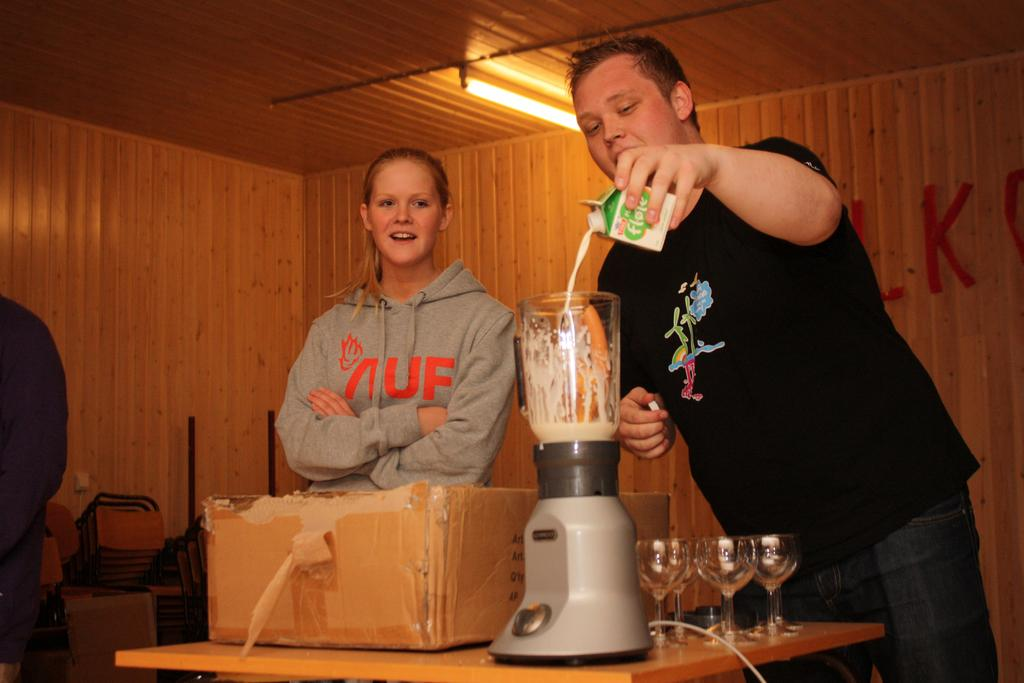<image>
Provide a brief description of the given image. A woman wearing aAUF sweatshirt watches a man pour liquid into a blender. 